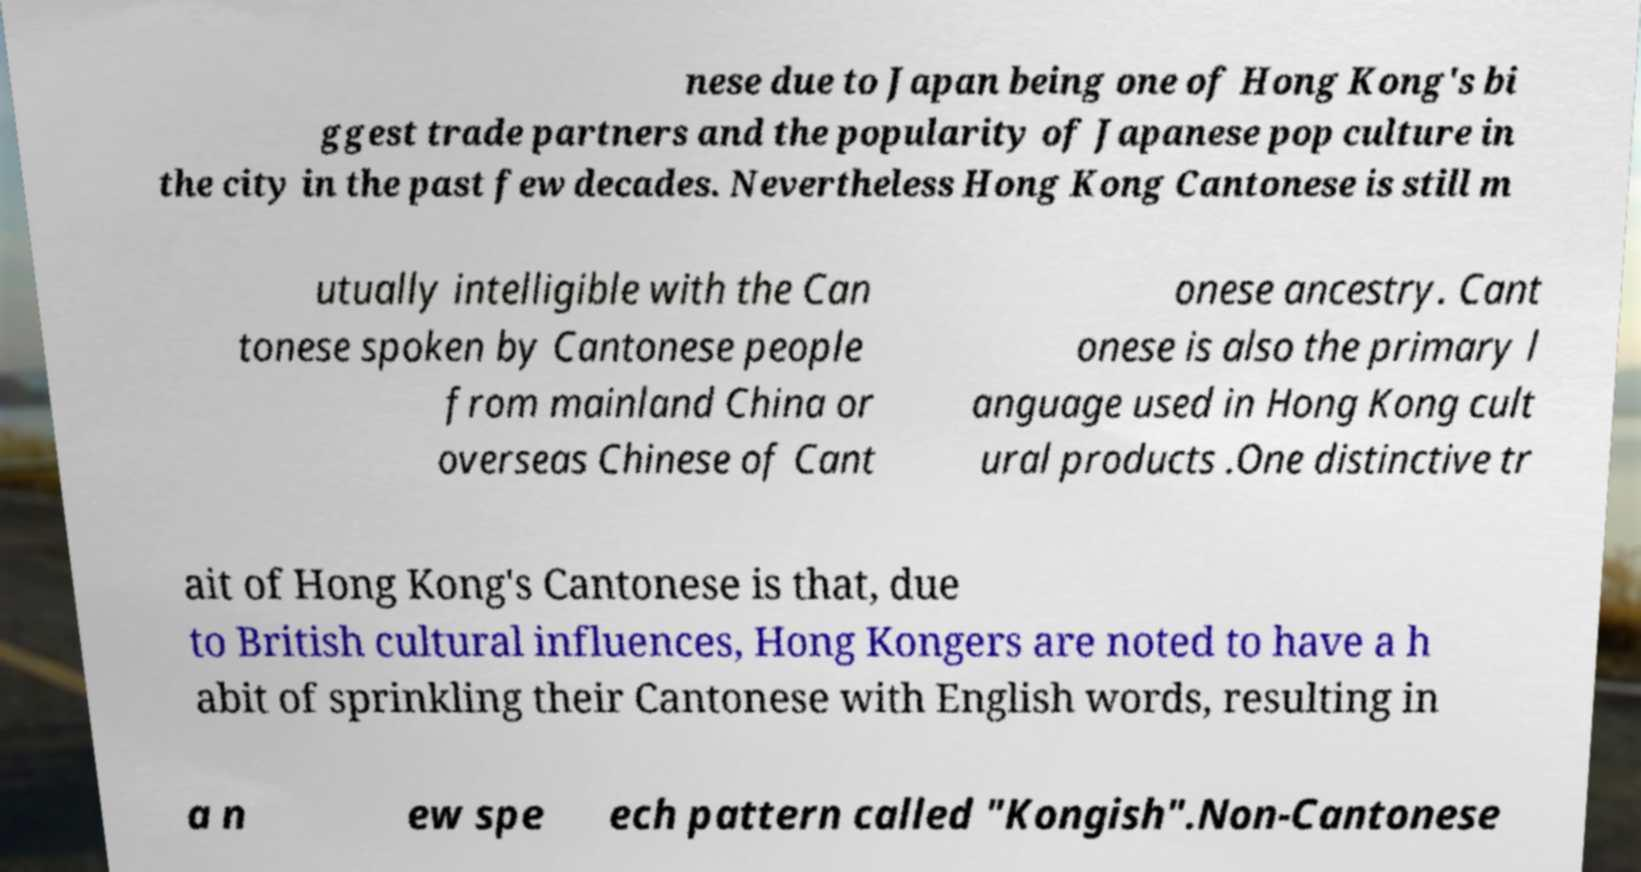What messages or text are displayed in this image? I need them in a readable, typed format. nese due to Japan being one of Hong Kong's bi ggest trade partners and the popularity of Japanese pop culture in the city in the past few decades. Nevertheless Hong Kong Cantonese is still m utually intelligible with the Can tonese spoken by Cantonese people from mainland China or overseas Chinese of Cant onese ancestry. Cant onese is also the primary l anguage used in Hong Kong cult ural products .One distinctive tr ait of Hong Kong's Cantonese is that, due to British cultural influences, Hong Kongers are noted to have a h abit of sprinkling their Cantonese with English words, resulting in a n ew spe ech pattern called "Kongish".Non-Cantonese 